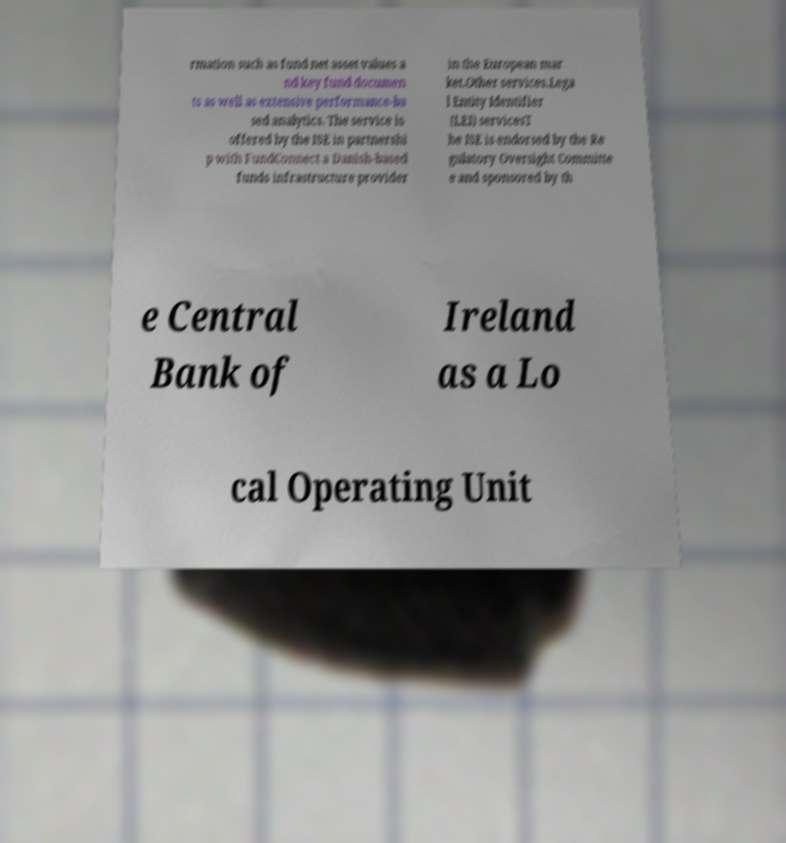Could you extract and type out the text from this image? rmation such as fund net asset values a nd key fund documen ts as well as extensive performance-ba sed analytics. The service is offered by the ISE in partnershi p with FundConnect a Danish-based funds infrastructure provider in the European mar ket.Other services.Lega l Entity Identifier (LEI) servicesT he ISE is endorsed by the Re gulatory Oversight Committe e and sponsored by th e Central Bank of Ireland as a Lo cal Operating Unit 